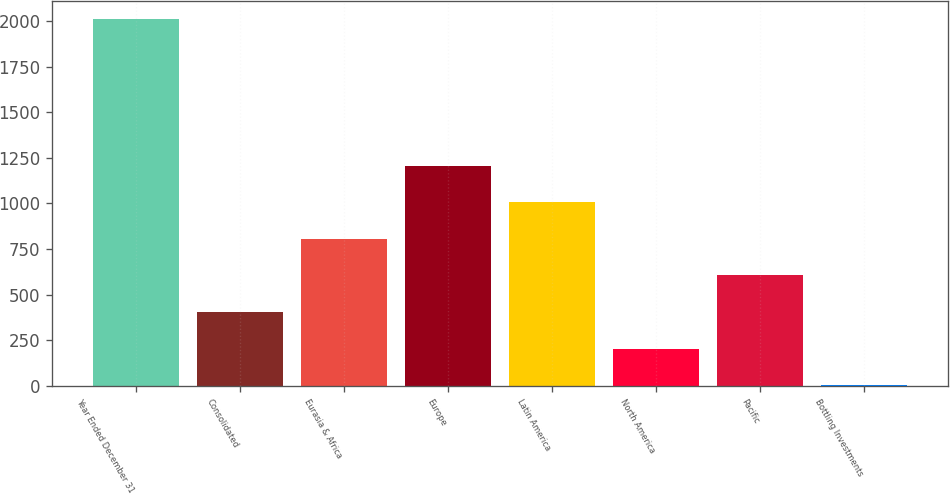Convert chart to OTSL. <chart><loc_0><loc_0><loc_500><loc_500><bar_chart><fcel>Year Ended December 31<fcel>Consolidated<fcel>Eurasia & Africa<fcel>Europe<fcel>Latin America<fcel>North America<fcel>Pacific<fcel>Bottling Investments<nl><fcel>2011<fcel>404.28<fcel>805.96<fcel>1207.64<fcel>1006.8<fcel>203.44<fcel>605.12<fcel>2.6<nl></chart> 